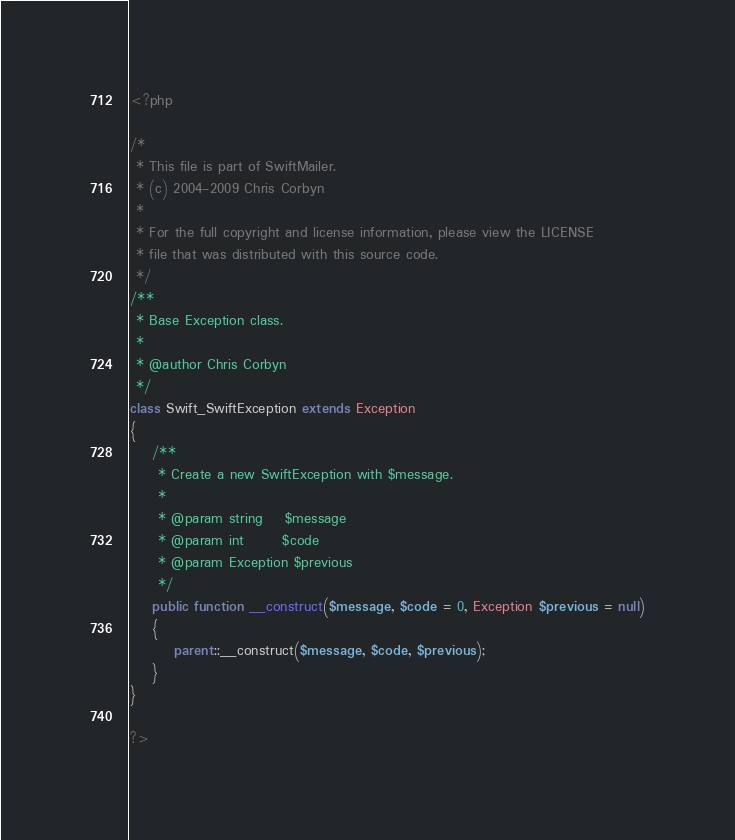<code> <loc_0><loc_0><loc_500><loc_500><_PHP_><?php

/*
 * This file is part of SwiftMailer.
 * (c) 2004-2009 Chris Corbyn
 *
 * For the full copyright and license information, please view the LICENSE
 * file that was distributed with this source code.
 */
/**
 * Base Exception class.
 *
 * @author Chris Corbyn
 */
class Swift_SwiftException extends Exception
{
    /**
     * Create a new SwiftException with $message.
     *
     * @param string    $message
     * @param int       $code
     * @param Exception $previous
     */
    public function __construct($message, $code = 0, Exception $previous = null)
    {
        parent::__construct($message, $code, $previous);
    }
}

?></code> 